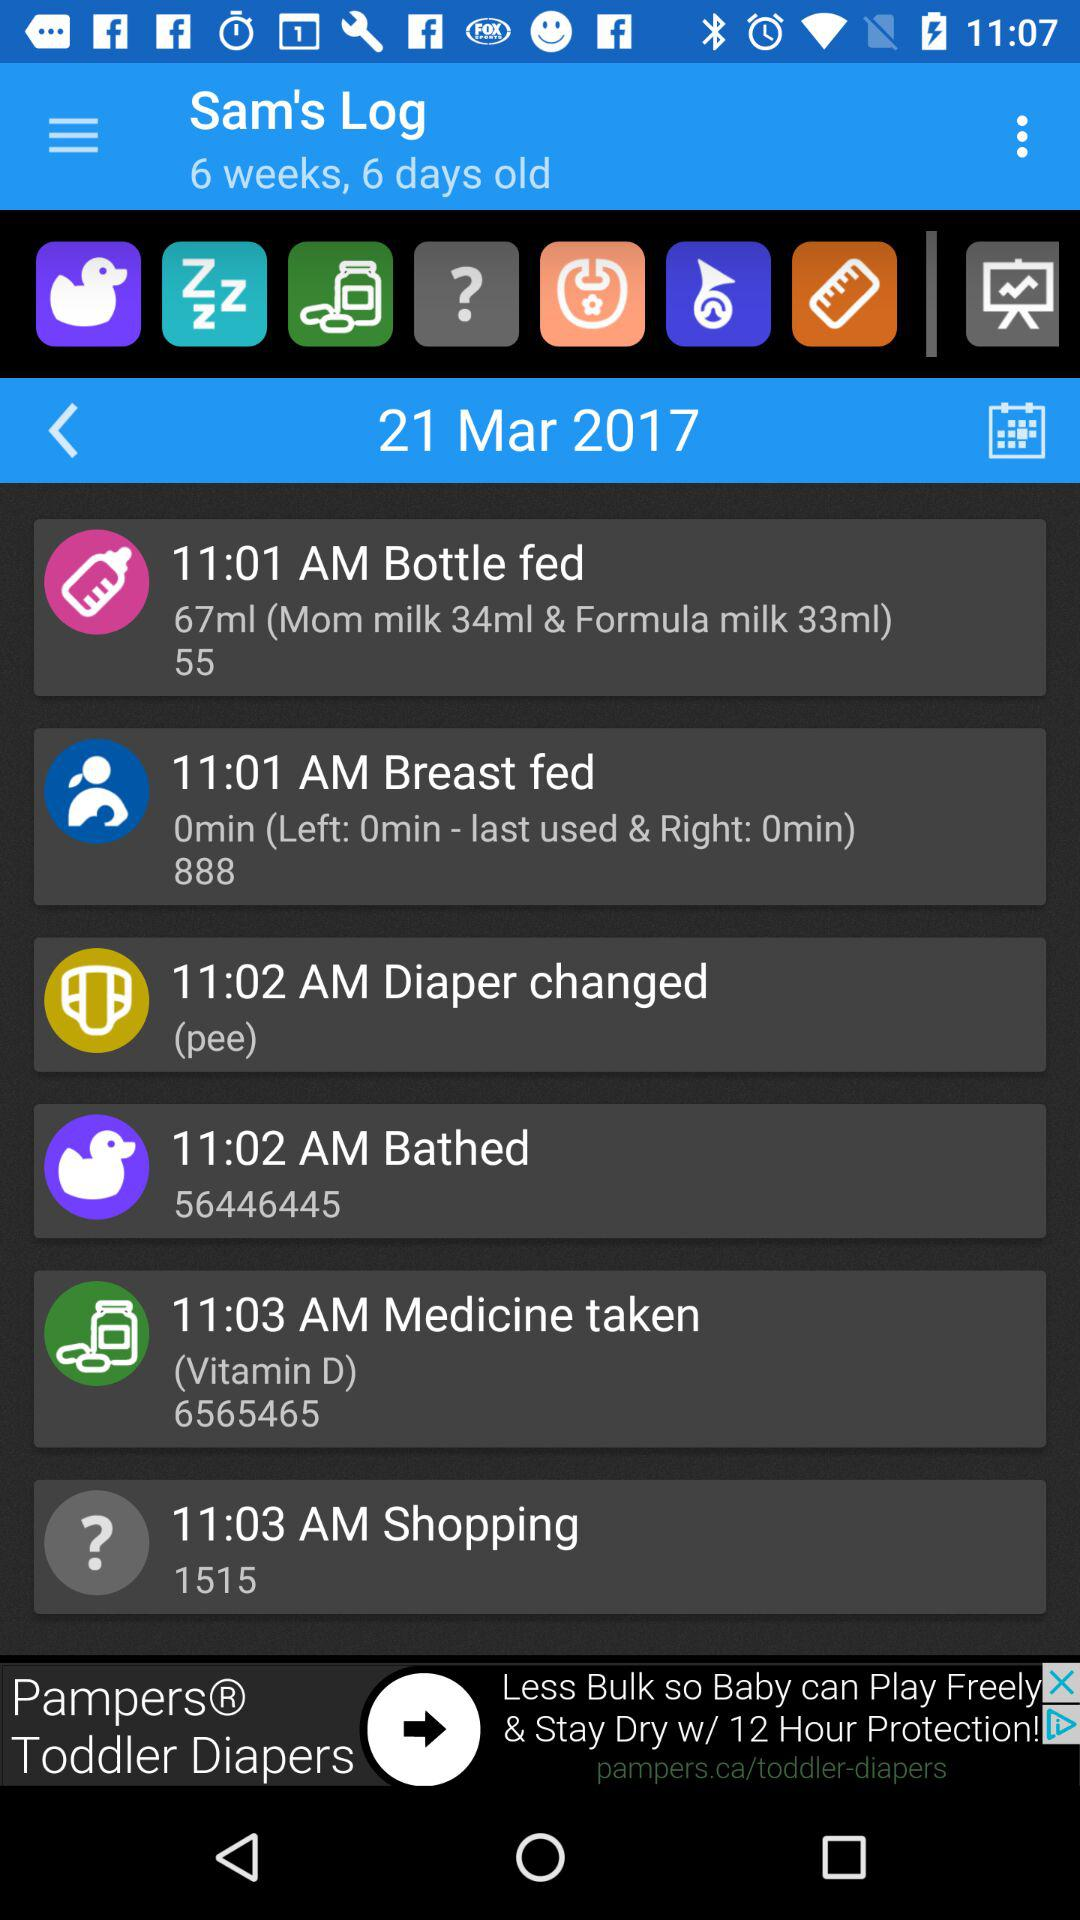What medicine has been taken? The medicine that has been taken is "Vitamin D". 